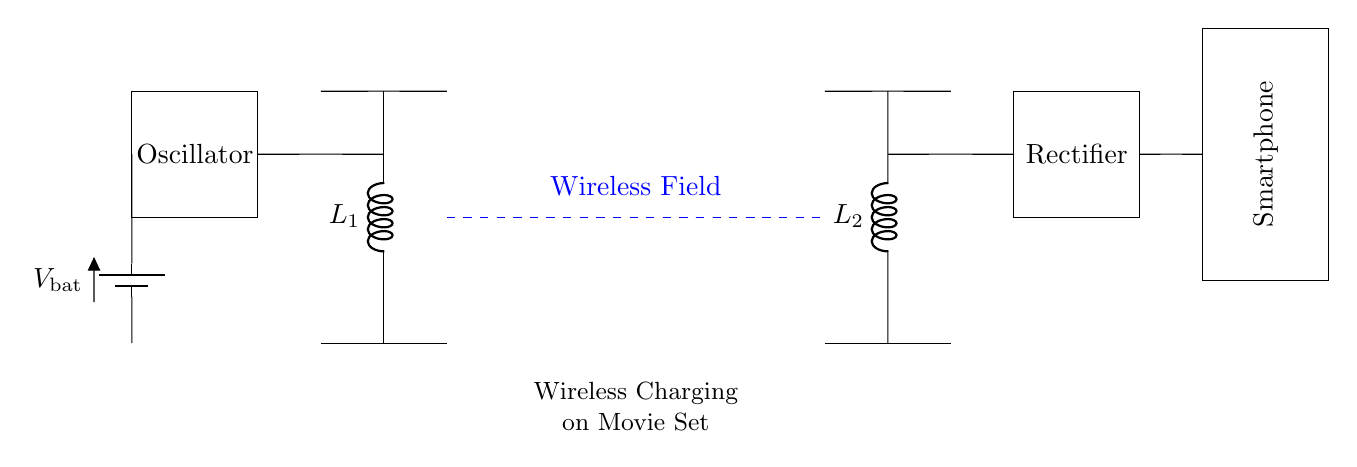What type of circuit is shown in the diagram? The circuit is a wireless charging circuit, which is indicated by the presence of transmitter and receiver coils along with a rectifier.
Answer: Wireless charging circuit What is the function of the oscillator in this circuit? The oscillator generates an alternating current to create a magnetic field, which is essential for wireless energy transfer between the transmitter and receiver coils.
Answer: Generate alternating current What do the dashed lines represent? The dashed lines indicate the wireless field where energy is transferred between the transmitter coil and the receiver coil without physical connections.
Answer: Wireless field What is the role of the rectifier? The rectifier converts the alternating current received by the receiver coil into direct current that can be used to charge the smartphone's battery.
Answer: Convert AC to DC What is the voltage source in the circuit? The voltage source is the battery indicated by the label, supplying necessary power to the oscillator and components involved in the transmission.
Answer: Battery voltage How are the two inductors connected in this circuit? The two inductors, L1 and L2, are arranged in a way that they create a magnetic coupling for efficient energy transfer, characteristic of wireless charging.
Answer: Magnetically coupled 